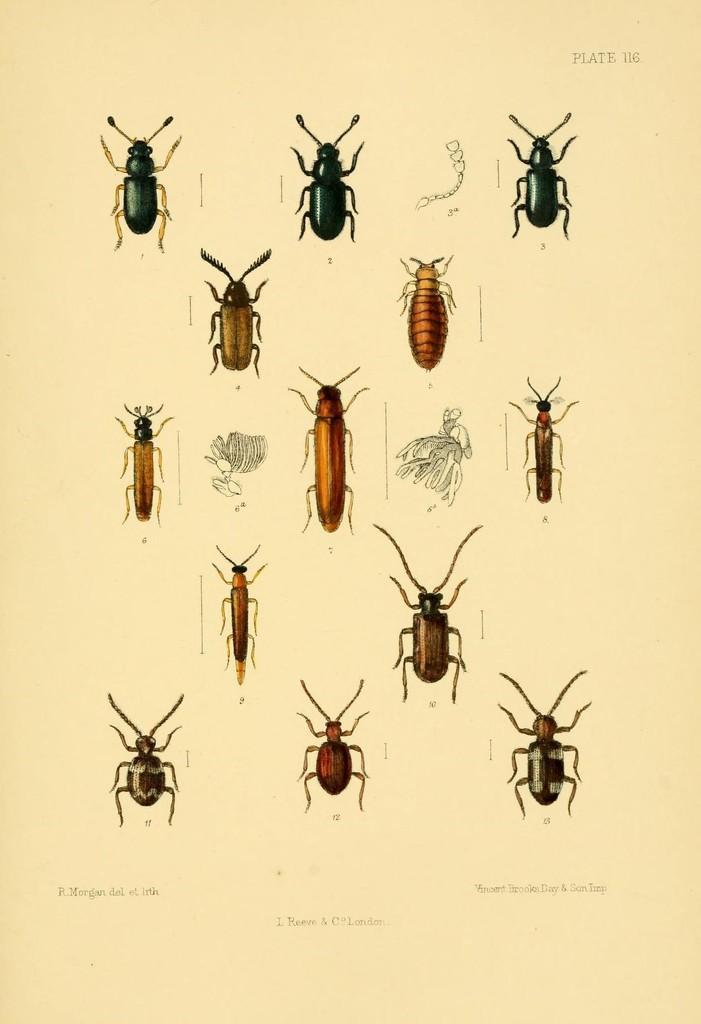How would you summarize this image in a sentence or two? In this image, we can see pictures of some insects and there is some text on the paper. 